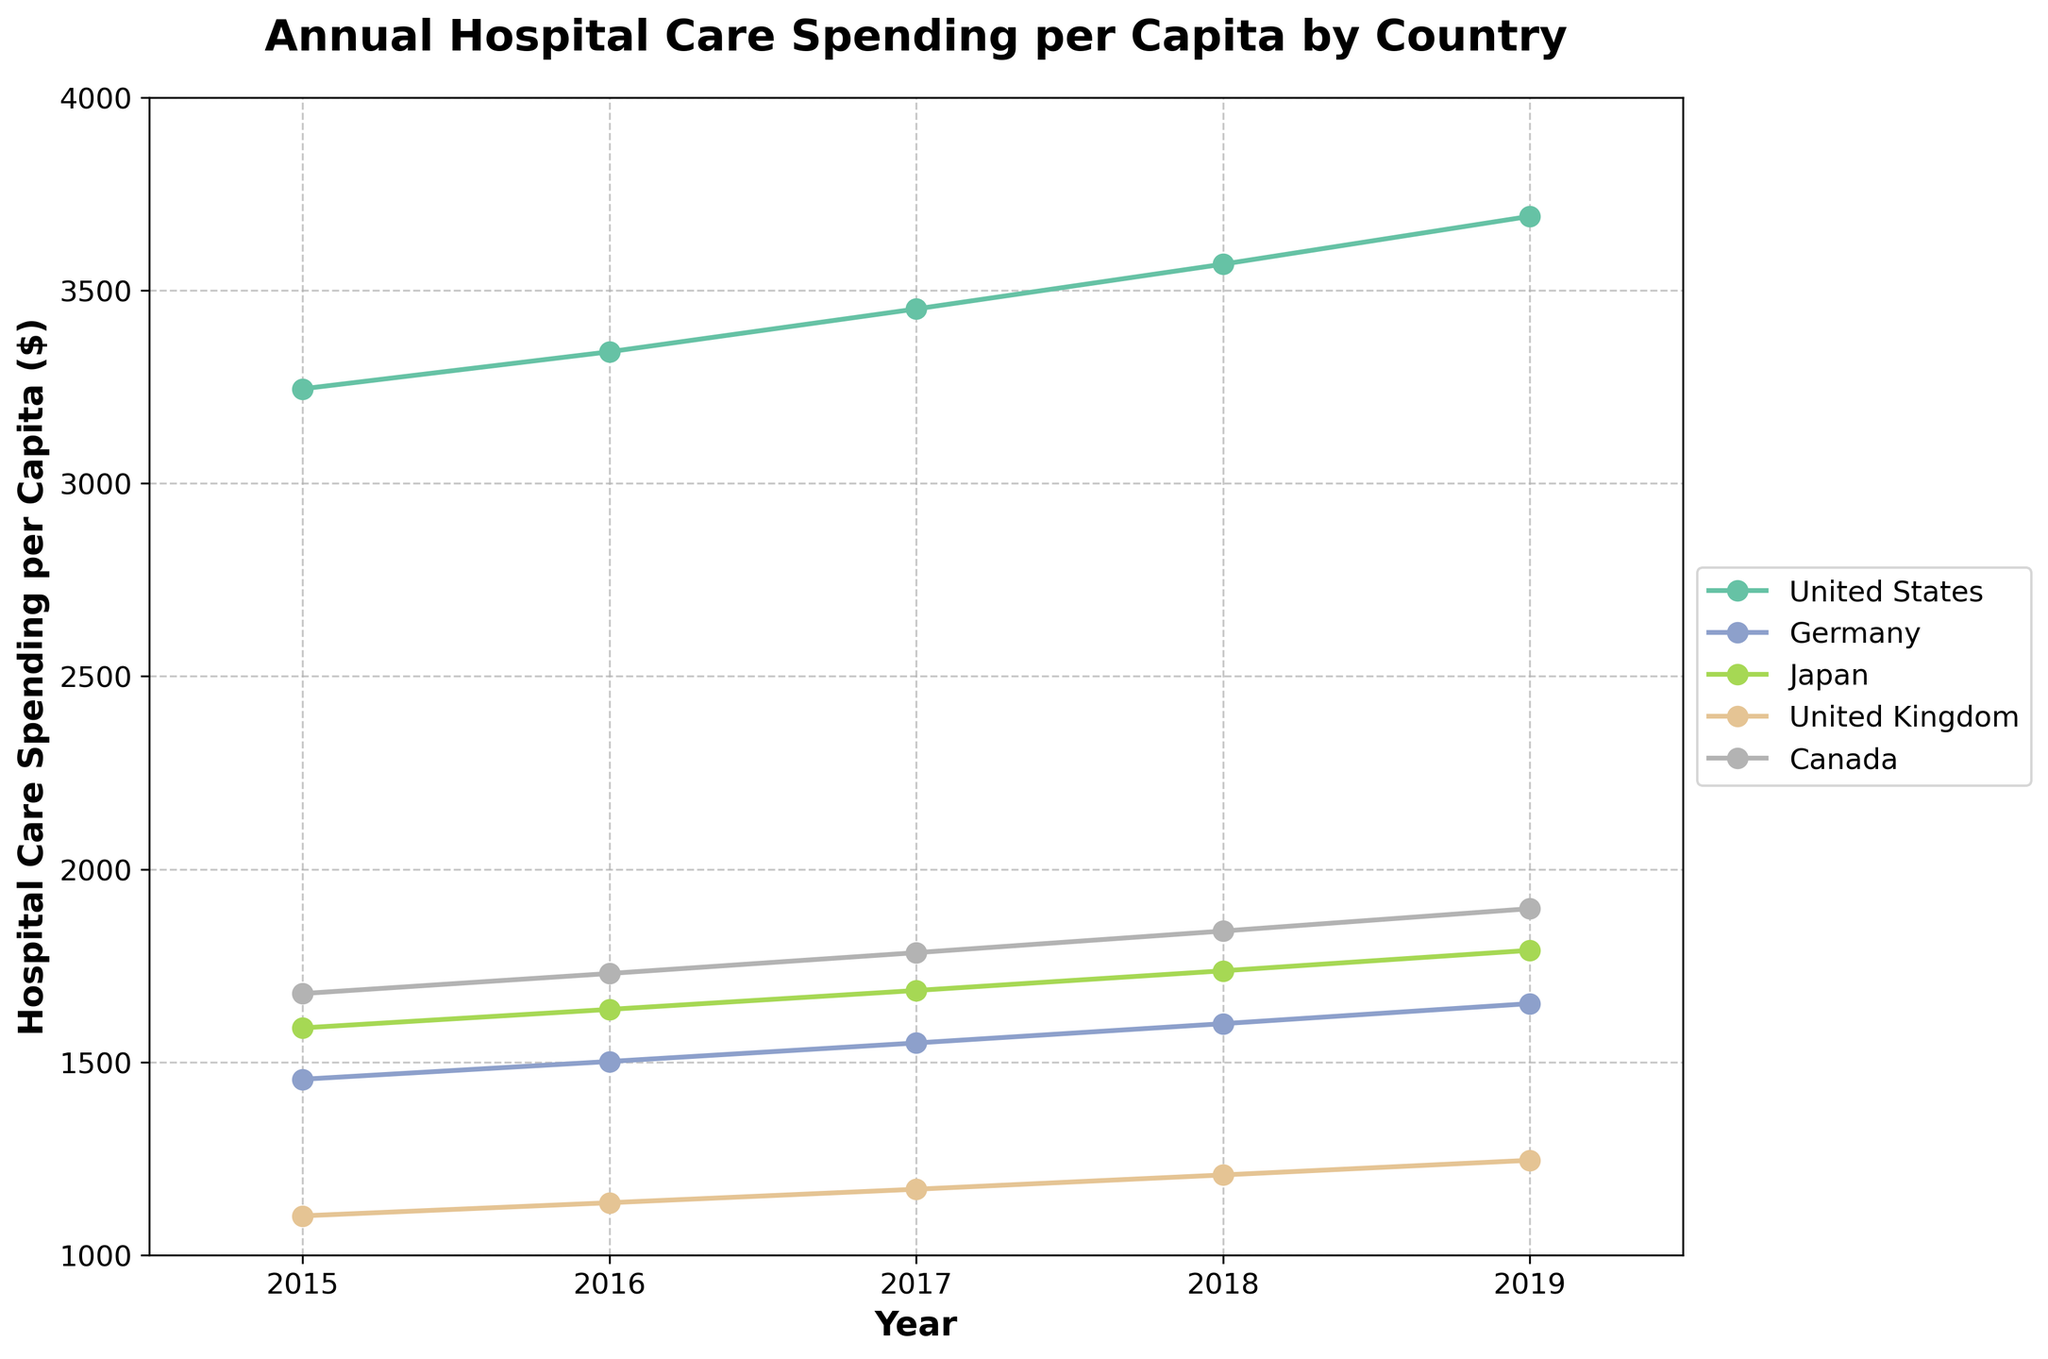What is the trend in hospital care spending per capita for the United States from 2015 to 2019? To answer this, observe the line representing the United States. The plot shows an increasing trend in hospital care spending from 2015 ($3245) to 2019 ($3692).
Answer: Increasing Which country had the highest hospital care spending per capita in 2019? By looking at the endpoints for 2019, which are the final data points on the lines for each country, we can see that the United States had the highest spending with a value of $3692.
Answer: United States How does the hospital care spending per capita in Canada in 2015 compare to that in Japan in the same year? Locate the 2015 data points for both Canada and Japan. The spending in Canada was $1678, while in Japan it was $1589, so Canada spent more.
Answer: Canada spent more What is the average hospital care spending per capita in Germany over the period 2015 to 2019? To calculate this, sum Germany’s hospital care spending values from 2015 to 2019 and divide by 5: (1456 + 1502 + 1550 + 1600 + 1652) / 5 = 7750 / 5 = 1550.
Answer: 1550 By how much did hospital care spending per capita increase in Japan between 2015 and 2019? Subtract the 2015 value from the 2019 value for Japan: 1790 - 1589 = 201.
Answer: 201 Which country had the lowest hospital care spending per capita in 2017? For 2017, compare the respective points for all countries. The United Kingdom had the lowest value at $1171.
Answer: United Kingdom In which year was the hospital care spending per capita roughly equal between Germany and Canada? Analyze the lines to find the intersection or closest points. In 2015, both countries' spending was almost the same: $1456 for Germany and $1678 for Canada.
Answer: 2015 What is the percentage increase in hospital care spending per capita for the United Kingdom from 2015 to 2019? Calculate the percentage increase with the formula ((New-Old)/Old)*100: ((1246 - 1102) / 1102) * 100 = 13.1%.
Answer: 13.1% Which country showed the most consistent increase in hospital care spending per capita from 2015 to 2019? Visual inspection shows that each country's spending increased over the years, but the United States exhibits the most consistent, steady increase.
Answer: United States 